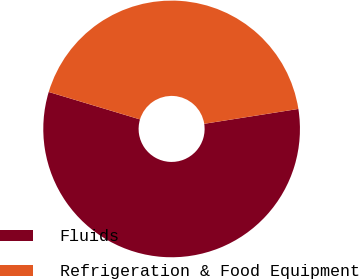Convert chart. <chart><loc_0><loc_0><loc_500><loc_500><pie_chart><fcel>Fluids<fcel>Refrigeration & Food Equipment<nl><fcel>57.14%<fcel>42.86%<nl></chart> 